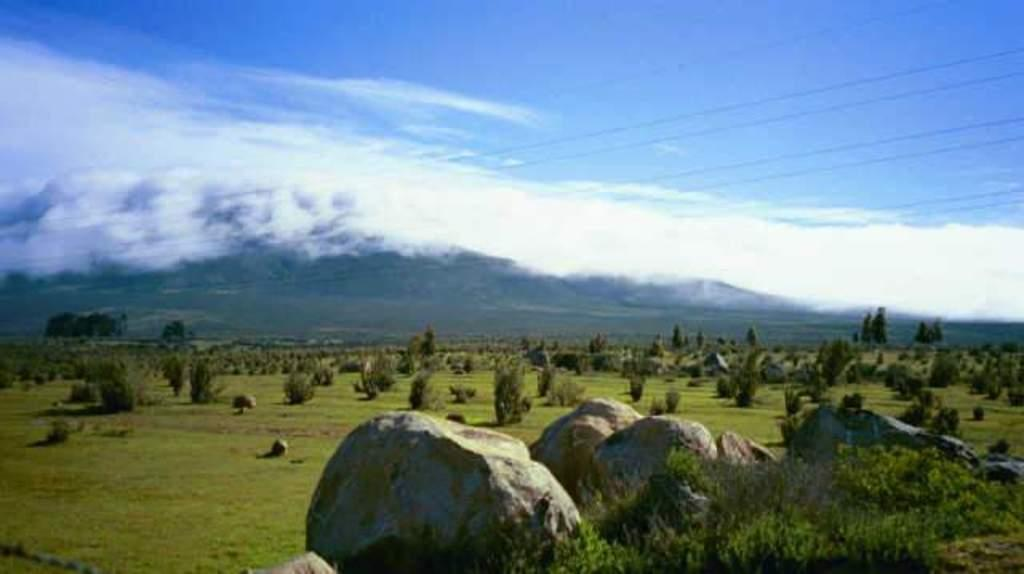What type of natural elements can be seen in the image? There are rocks, plants, grass, and trees in the image. What man-made objects are present in the image? There are wires in the image. What can be seen in the background of the image? The sky is visible in the background of the image, and there are clouds in the sky. What type of jam is being served on the minister's plate in the image? There is no minister or plate with jam present in the image. How many times does the minister fold the paper in the image? There is no minister or paper-folding activity depicted in the image. 